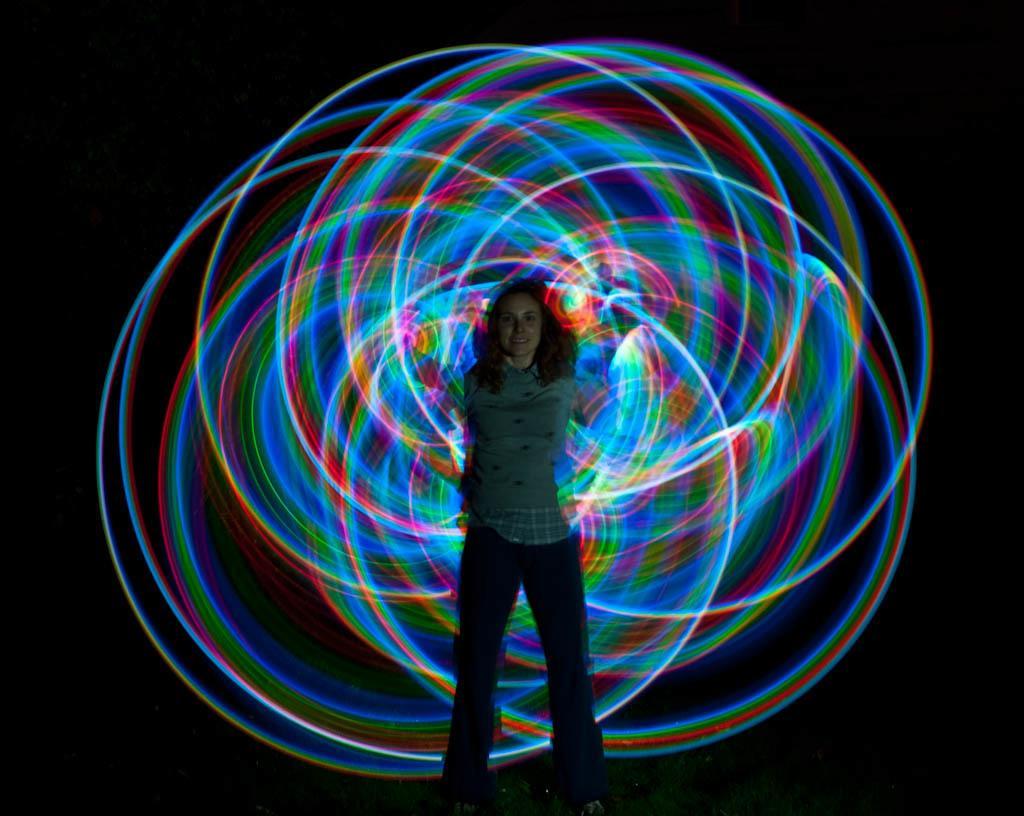Describe this image in one or two sentences. In the center of the image there is a woman standing on the ground. 